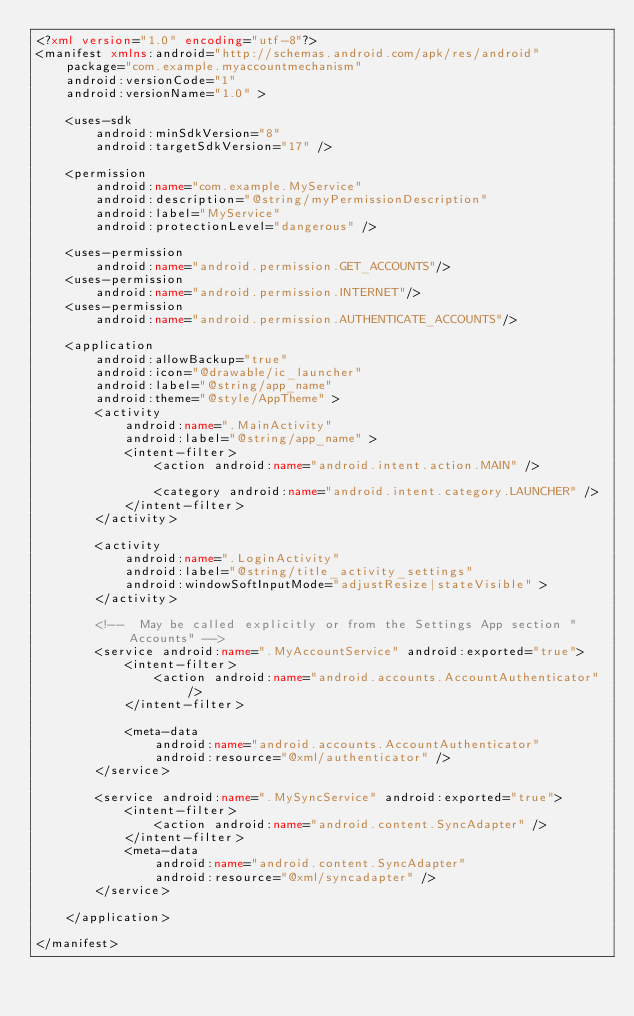<code> <loc_0><loc_0><loc_500><loc_500><_XML_><?xml version="1.0" encoding="utf-8"?>
<manifest xmlns:android="http://schemas.android.com/apk/res/android"
    package="com.example.myaccountmechanism"
    android:versionCode="1"
    android:versionName="1.0" >

    <uses-sdk
        android:minSdkVersion="8"
        android:targetSdkVersion="17" />

    <permission
        android:name="com.example.MyService"
        android:description="@string/myPermissionDescription"
        android:label="MyService"
        android:protectionLevel="dangerous" />
    
    <uses-permission
        android:name="android.permission.GET_ACCOUNTS"/>
    <uses-permission 
        android:name="android.permission.INTERNET"/>
    <uses-permission
        android:name="android.permission.AUTHENTICATE_ACCOUNTS"/>

    <application
        android:allowBackup="true"
        android:icon="@drawable/ic_launcher"
        android:label="@string/app_name"
        android:theme="@style/AppTheme" >
        <activity
            android:name=".MainActivity"
            android:label="@string/app_name" >
            <intent-filter>
                <action android:name="android.intent.action.MAIN" />

                <category android:name="android.intent.category.LAUNCHER" />
            </intent-filter>
        </activity>

        <activity
            android:name=".LoginActivity"
            android:label="@string/title_activity_settings"
            android:windowSoftInputMode="adjustResize|stateVisible" >
        </activity>

        <!--  May be called explicitly or from the Settings App section "Accounts" -->
        <service android:name=".MyAccountService" android:exported="true">
            <intent-filter>
                <action android:name="android.accounts.AccountAuthenticator" />
            </intent-filter>

            <meta-data
                android:name="android.accounts.AccountAuthenticator"
                android:resource="@xml/authenticator" />
        </service>
        
        <service android:name=".MySyncService" android:exported="true">
            <intent-filter>
                <action android:name="android.content.SyncAdapter" />
            </intent-filter>
            <meta-data
                android:name="android.content.SyncAdapter"
                android:resource="@xml/syncadapter" />
        </service>
        
    </application>

</manifest>
</code> 